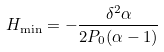Convert formula to latex. <formula><loc_0><loc_0><loc_500><loc_500>H _ { \min } = - \frac { \delta ^ { 2 } \alpha } { 2 P _ { 0 } ( \alpha - 1 ) }</formula> 